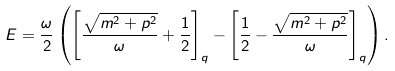<formula> <loc_0><loc_0><loc_500><loc_500>E = \frac { \omega } { 2 } \left ( \left [ \frac { \sqrt { m ^ { 2 } + p ^ { 2 } } } { \omega } + \frac { 1 } { 2 } \right ] _ { q } - \left [ \frac { 1 } { 2 } - \frac { \sqrt { m ^ { 2 } + p ^ { 2 } } } { \omega } \right ] _ { q } \right ) .</formula> 